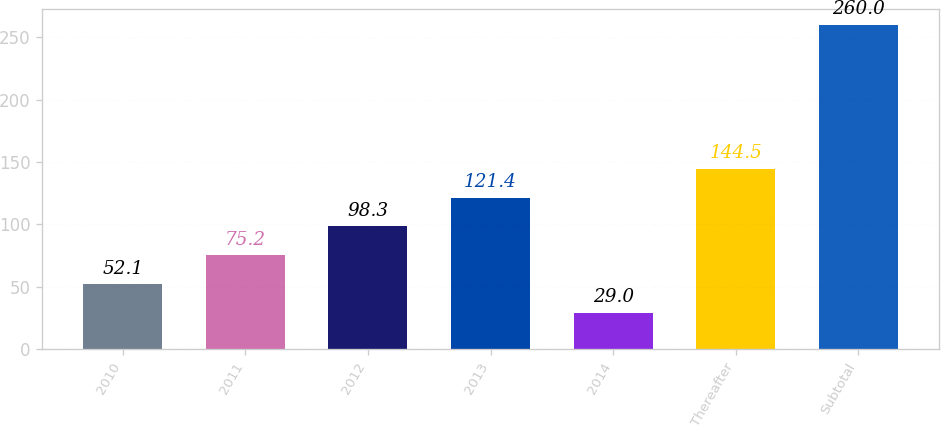<chart> <loc_0><loc_0><loc_500><loc_500><bar_chart><fcel>2010<fcel>2011<fcel>2012<fcel>2013<fcel>2014<fcel>Thereafter<fcel>Subtotal<nl><fcel>52.1<fcel>75.2<fcel>98.3<fcel>121.4<fcel>29<fcel>144.5<fcel>260<nl></chart> 